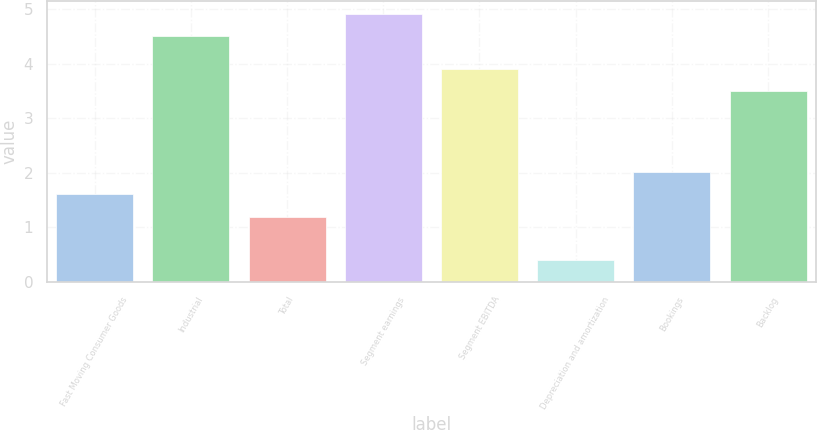Convert chart to OTSL. <chart><loc_0><loc_0><loc_500><loc_500><bar_chart><fcel>Fast Moving Consumer Goods<fcel>Industrial<fcel>Total<fcel>Segment earnings<fcel>Segment EBITDA<fcel>Depreciation and amortization<fcel>Bookings<fcel>Backlog<nl><fcel>1.61<fcel>4.5<fcel>1.2<fcel>4.91<fcel>3.91<fcel>0.4<fcel>2.02<fcel>3.5<nl></chart> 